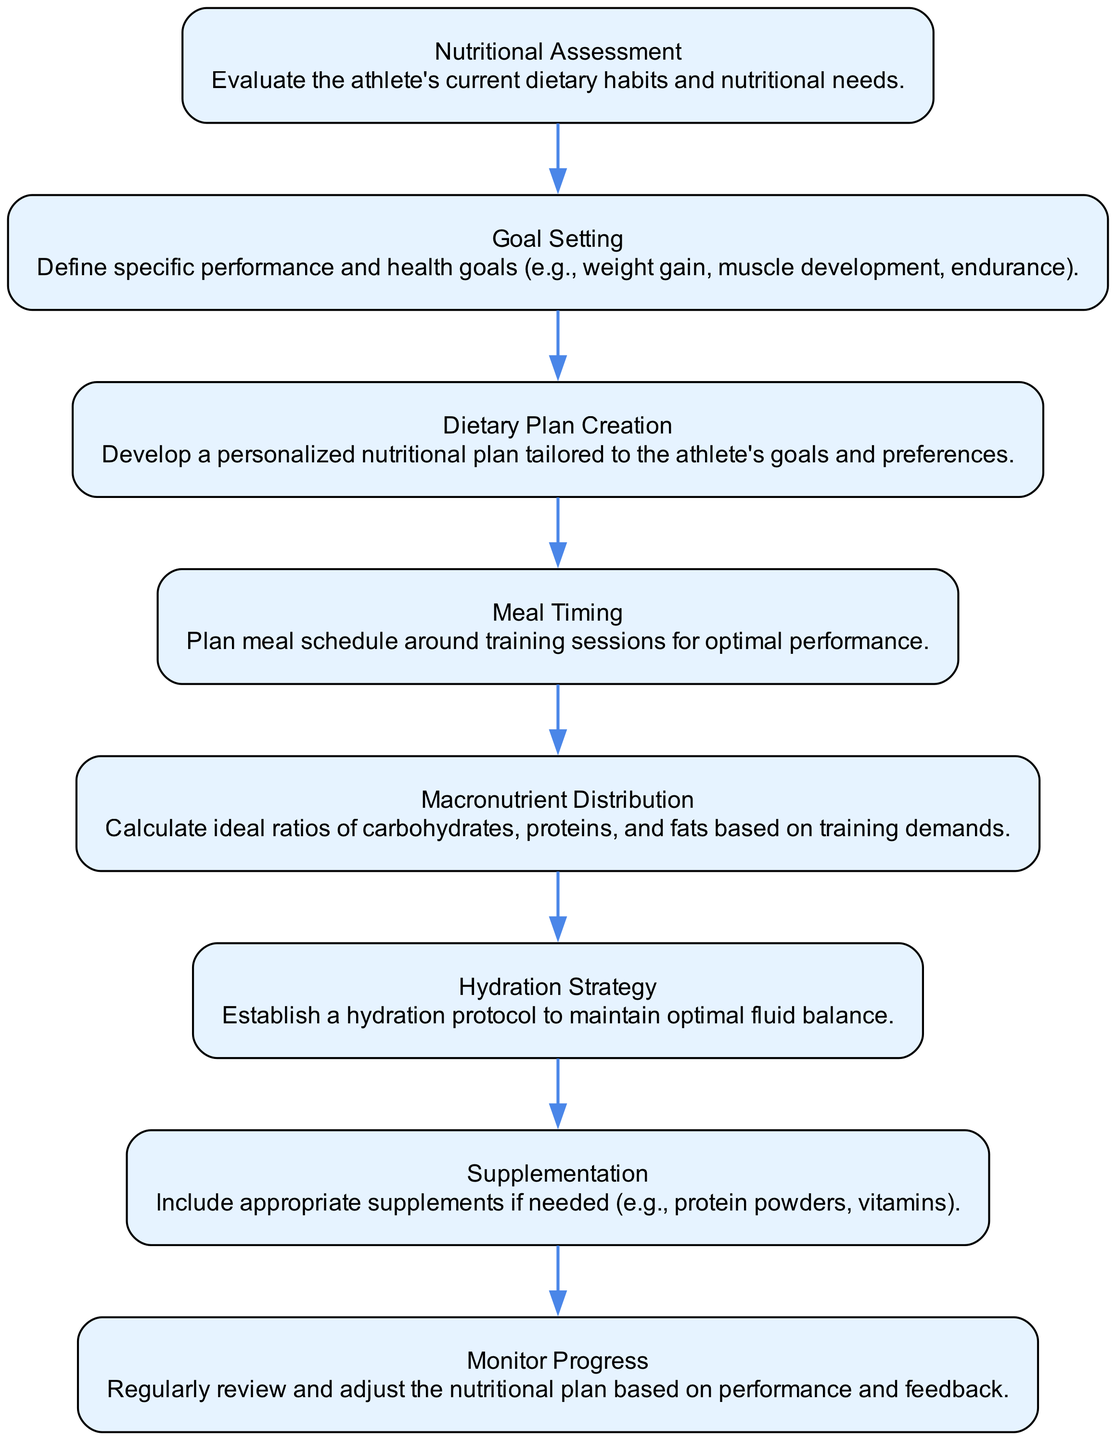What is the first step in the process? The first step, as indicated by the first node in the flowchart, is the "Nutritional Assessment," which evaluates the athlete's current dietary habits and nutritional needs.
Answer: Nutritional Assessment How many nodes are present in the diagram? By counting all the unique elements listed, there are a total of 8 nodes in the flowchart: Nutritional Assessment, Goal Setting, Dietary Plan Creation, Meal Timing, Macronutrient Distribution, Hydration Strategy, Supplementation, and Monitor Progress.
Answer: 8 What occurs after setting goals? According to the flowchart, after "Goal Setting," the next step is "Dietary Plan Creation," where a personalized nutritional plan is developed based on the defined goals.
Answer: Dietary Plan Creation What is the purpose of the hydration strategy? The "Hydration Strategy" node describes the importance of establishing a hydration protocol to maintain optimal fluid balance, essential for athletic performance.
Answer: Maintain fluid balance Which two nodes are directly linked? The nodes "Meal Timing" and "Macronutrient Distribution" are directly linked; after planning meal timing, the next step is to calculate macronutrient ratios based on training demands.
Answer: Meal Timing and Macronutrient Distribution What is the final step in the flowchart? The last node in the sequential flow is "Monitor Progress," indicating the ongoing process of regularly reviewing and adjusting the nutritional plan.
Answer: Monitor Progress Is supplementation included as a part of the plan? Yes, there is a dedicated node for "Supplementation," which indicates that appropriate supplements may be included in the nutritional plan if needed.
Answer: Yes How is macronutrient distribution determined? In the flowchart, the ideal ratios of carbohydrates, proteins, and fats are calculated based on training demands outlined in the "Macronutrient Distribution" step.
Answer: Based on training demands What does meal timing involve? The "Meal Timing" node focuses on planning the meal schedule around training sessions to enhance athletic performance, emphasizing its importance.
Answer: Plan meal schedule around training sessions 